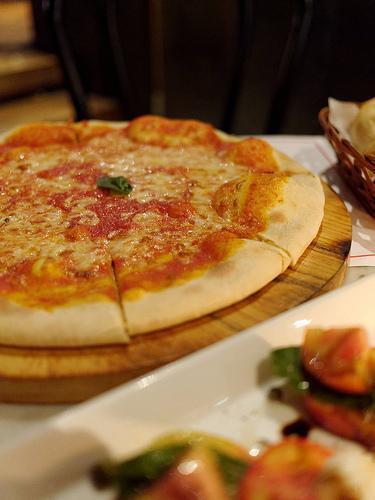How many slices does the pizza have?
Give a very brief answer. 8. 